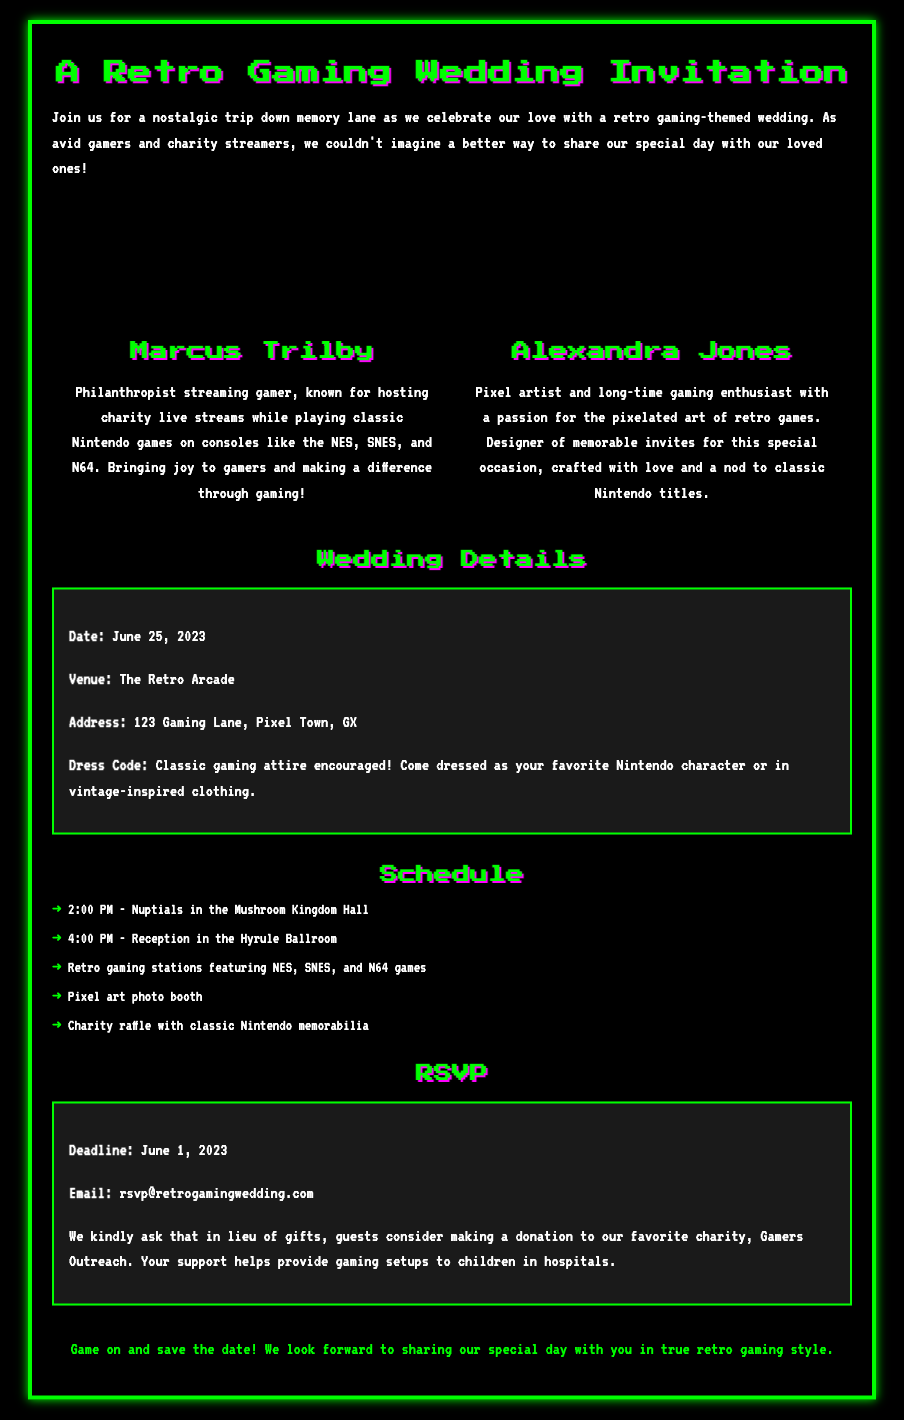What is the date of the wedding? The wedding date is explicitly stated in the details section of the invitation.
Answer: June 25, 2023 What is the venue for the wedding? The venue name is provided in the wedding details section.
Answer: The Retro Arcade Who are the couple getting married? The couple's names are listed in the couple information section.
Answer: Marcus Trilby and Alexandra Jones What time do the nuptials start? The start time for the nuptials is mentioned in the schedule section.
Answer: 2:00 PM What is the dress code for the wedding? The dress code is included in the wedding details section of the invitation.
Answer: Classic gaming attire encouraged What is the deadline for RSVPs? The RSVP deadline is specified in the RSVP details section.
Answer: June 1, 2023 Which charity is mentioned for donations? The charity is referenced in the RSVP section of the invitation.
Answer: Gamers Outreach What type of games will be featured at the reception? The types of games are noted in the schedule section of the invitation.
Answer: NES, SNES, and N64 games What activity is planned for guests at the wedding? The activities for guests are outlined in the schedule section.
Answer: Retro gaming stations 